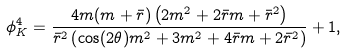Convert formula to latex. <formula><loc_0><loc_0><loc_500><loc_500>\phi _ { K } ^ { 4 } = \frac { 4 m ( m + \bar { r } ) \left ( 2 m ^ { 2 } + 2 \bar { r } m + \bar { r } ^ { 2 } \right ) } { \bar { r } ^ { 2 } \left ( \cos ( 2 \theta ) m ^ { 2 } + 3 m ^ { 2 } + 4 \bar { r } m + 2 \bar { r } ^ { 2 } \right ) } + 1 ,</formula> 